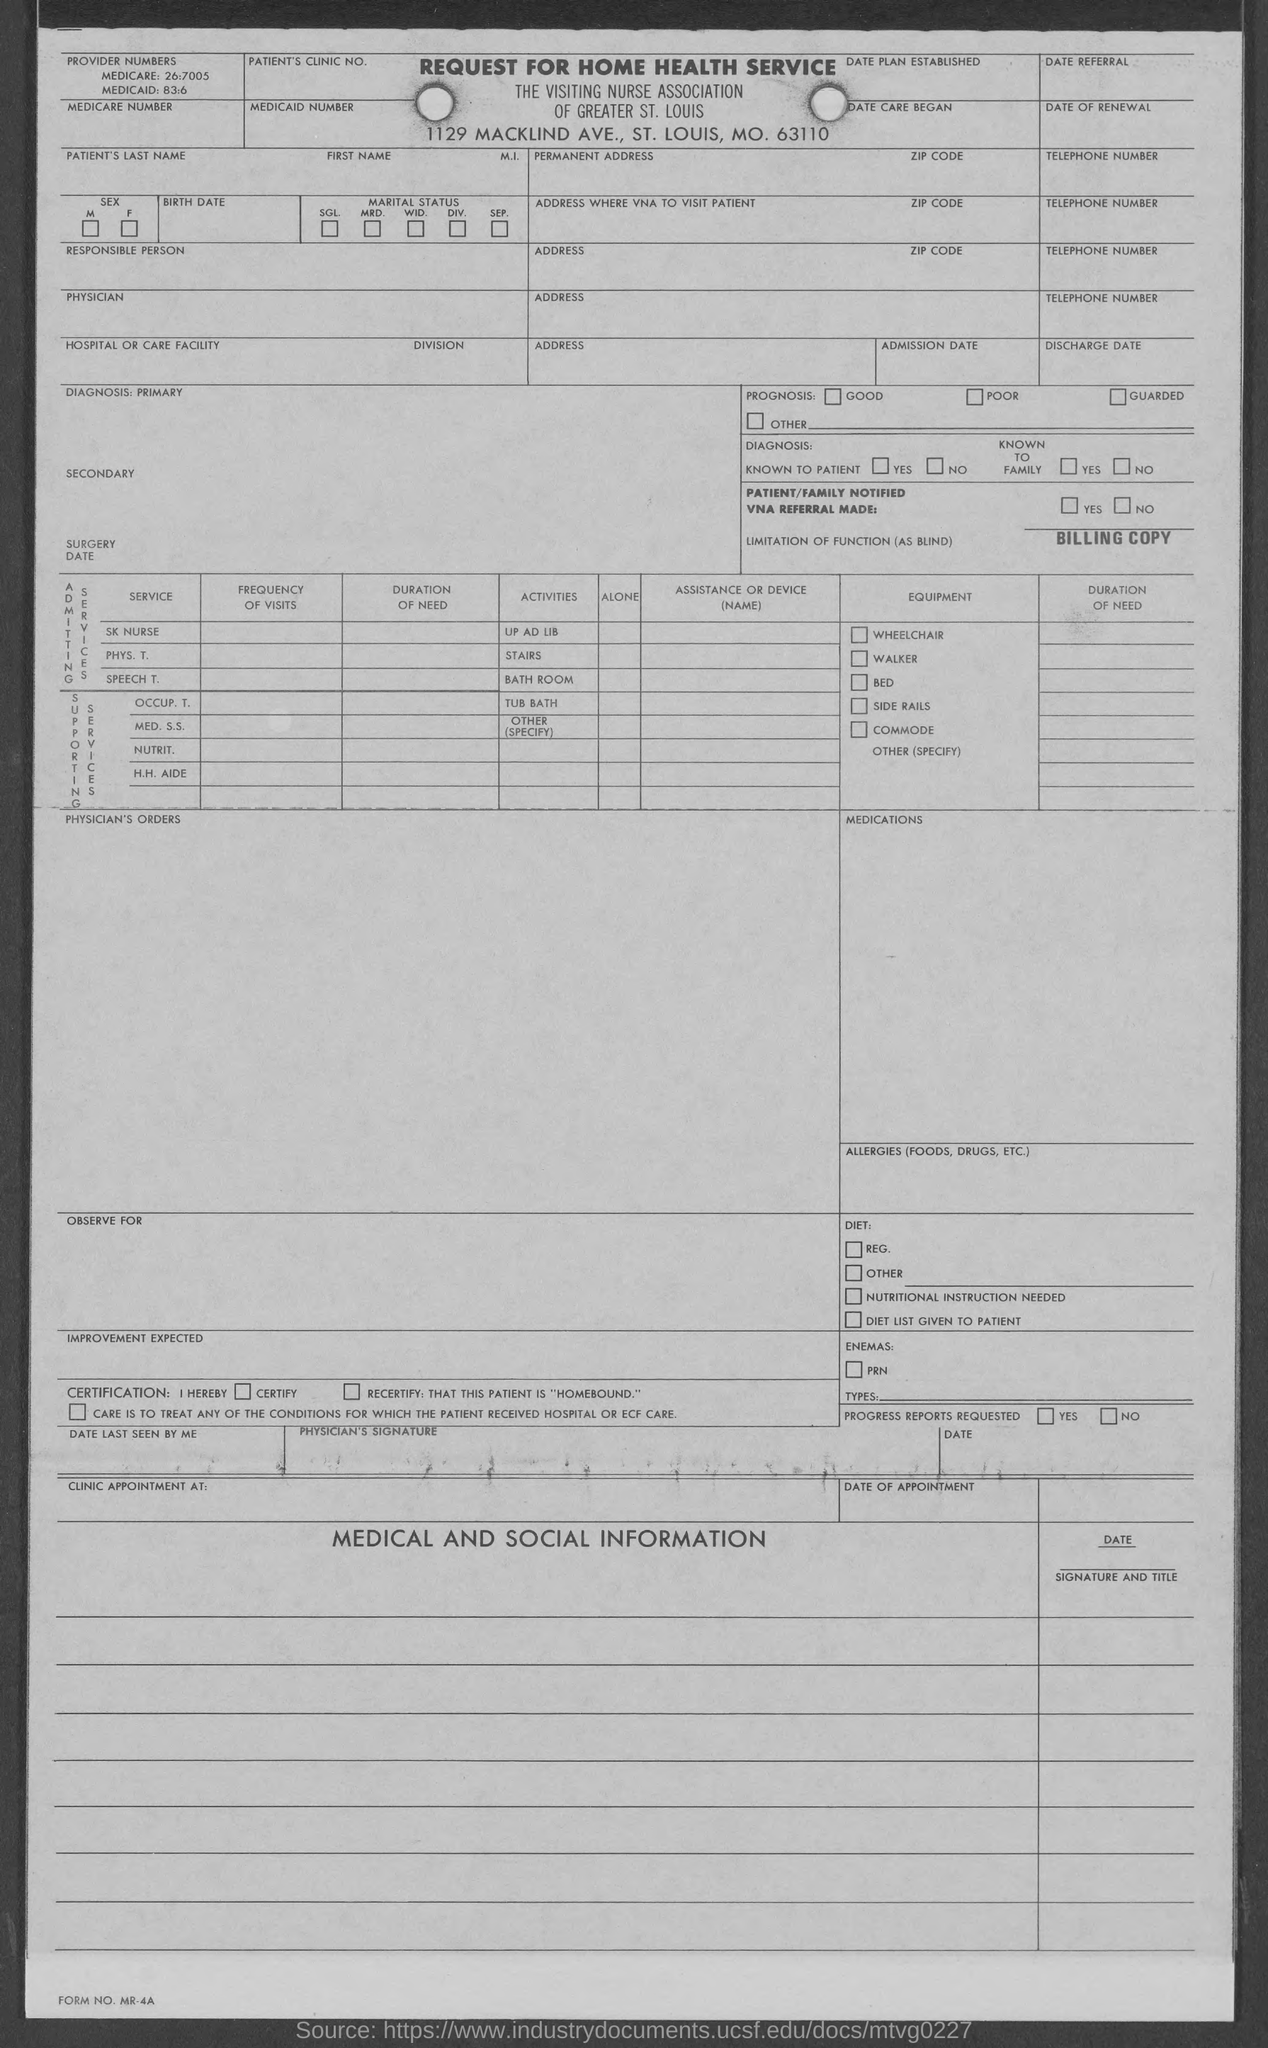What is the zip code mentioned in the form?
Give a very brief answer. 63110. What is the FORM NO. mentioned at bottom left corner?
Provide a short and direct response. MR-4A. What is the title of the form?
Ensure brevity in your answer.  REQUEST FOR HOME HEALTH SERVICE. 